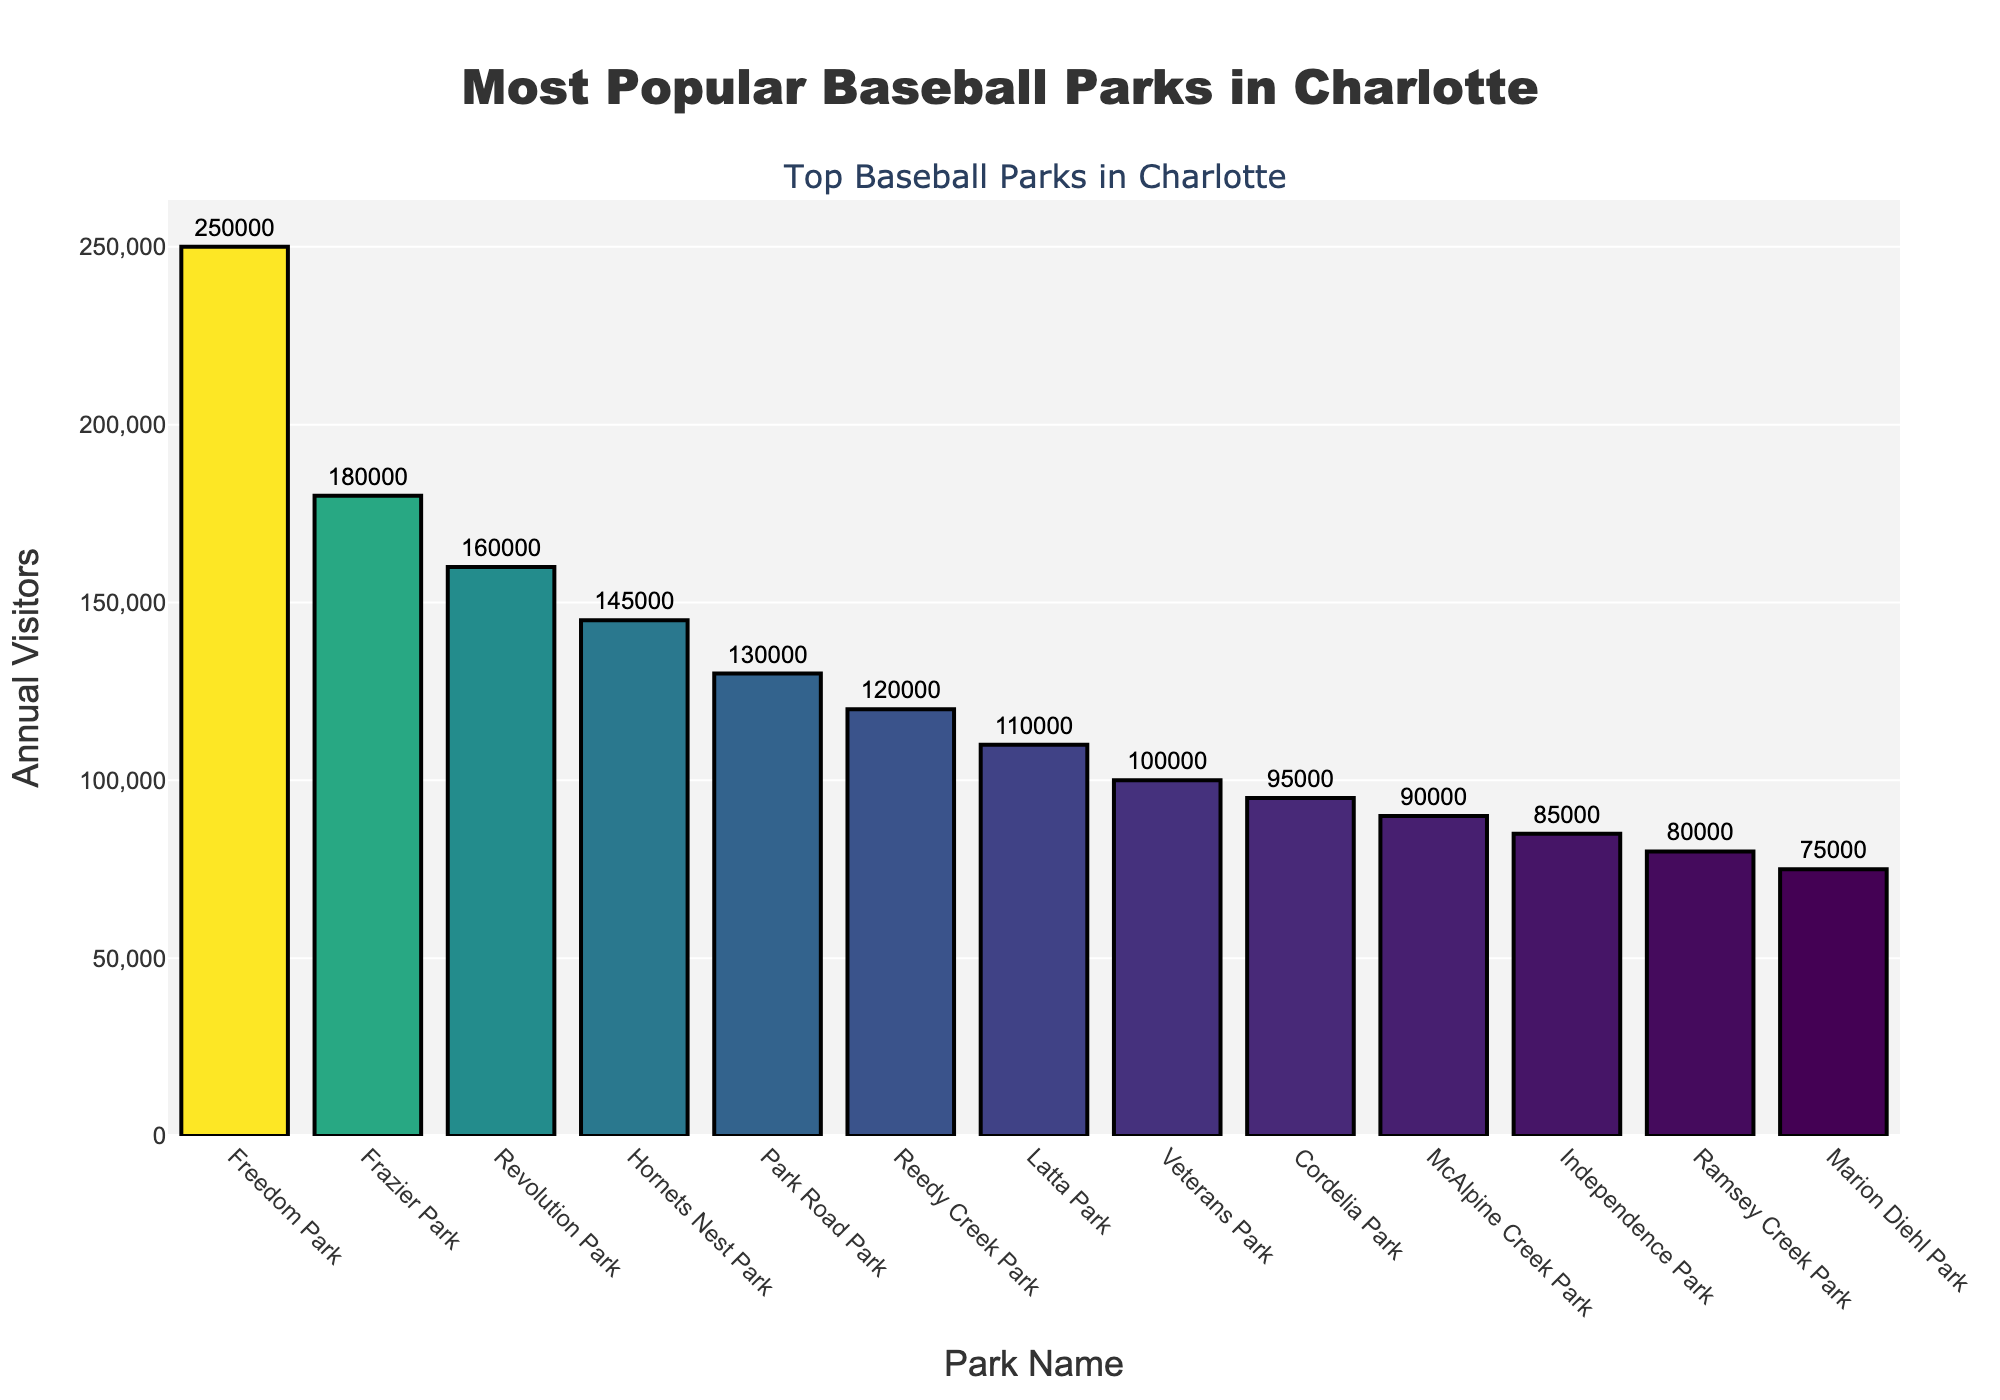Which park has the highest number of annual visitors? The highest bar in the chart represents the park with the most annual visitors.
Answer: Freedom Park What is the difference in annual visitors between the park with the highest visitors and the park with the lowest visitors in the top 10? The park with the highest visitors, Freedom Park, has 250,000 visitors, and the park with the lowest visitors among the top 10, McAlpine Creek Park, has 90,000 visitors. The difference is 250,000 - 90,000.
Answer: 160,000 Which parks have fewer than 150,000 annual visitors? By examining the heights of the bars, the parks with less than 150,000 visitors are: Park Road Park, Reedy Creek Park, Latta Park, Veterans Park, Cordelia Park, and McAlpine Creek Park.
Answer: Park Road Park, Reedy Creek Park, Latta Park, Veterans Park, Cordelia Park, McAlpine Creek Park How many more annual visitors does Freedom Park have compared to Hornets Nest Park? Freedom Park has 250,000 visitors, while Hornets Nest Park has 145,000 visitors. The difference is 250,000 - 145,000.
Answer: 105,000 What is the average number of visitors for the top 5 parks? The top 5 parks are Freedom Park, Frazier Park, Revolution Park, Hornets Nest Park, and Park Road Park. Sum their visitors: 250,000 + 180,000 + 160,000 + 145,000 + 130,000 = 865,000. Divide the total by 5.
Answer: 173,000 Which two parks have nearly equal visitor numbers? By checking the bar heights, the parks with nearly equal visitors are Revolution Park (160,000) and Frazier Park (180,000).
Answer: Revolution Park, Frazier Park What is the combined number of annual visitors for the three least popular parks in the top 10? The three parks are Cordelia Park (95,000), McAlpine Creek Park (90,000), and Independence Park (85,000). Sum their visitors: 95,000 + 90,000 + 85,000.
Answer: 270,000 For every 1 visitor to Veterans Park, how many visitors go to Reedy Creek Park? Veterans Park has 100,000 visitors and Reedy Creek Park has 120,000 visitors. The ratio is 120,000 / 100,000.
Answer: 1.2 visitors 